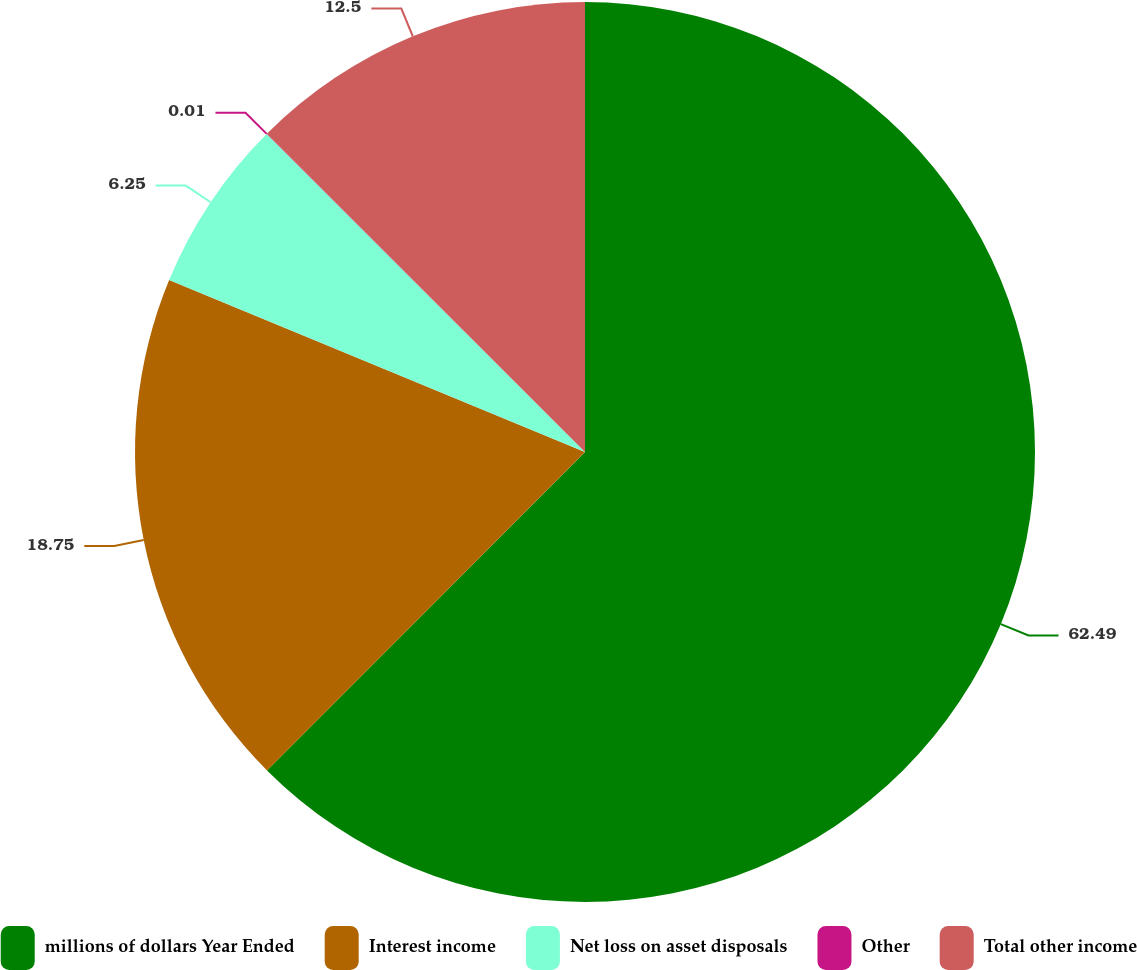Convert chart. <chart><loc_0><loc_0><loc_500><loc_500><pie_chart><fcel>millions of dollars Year Ended<fcel>Interest income<fcel>Net loss on asset disposals<fcel>Other<fcel>Total other income<nl><fcel>62.49%<fcel>18.75%<fcel>6.25%<fcel>0.01%<fcel>12.5%<nl></chart> 